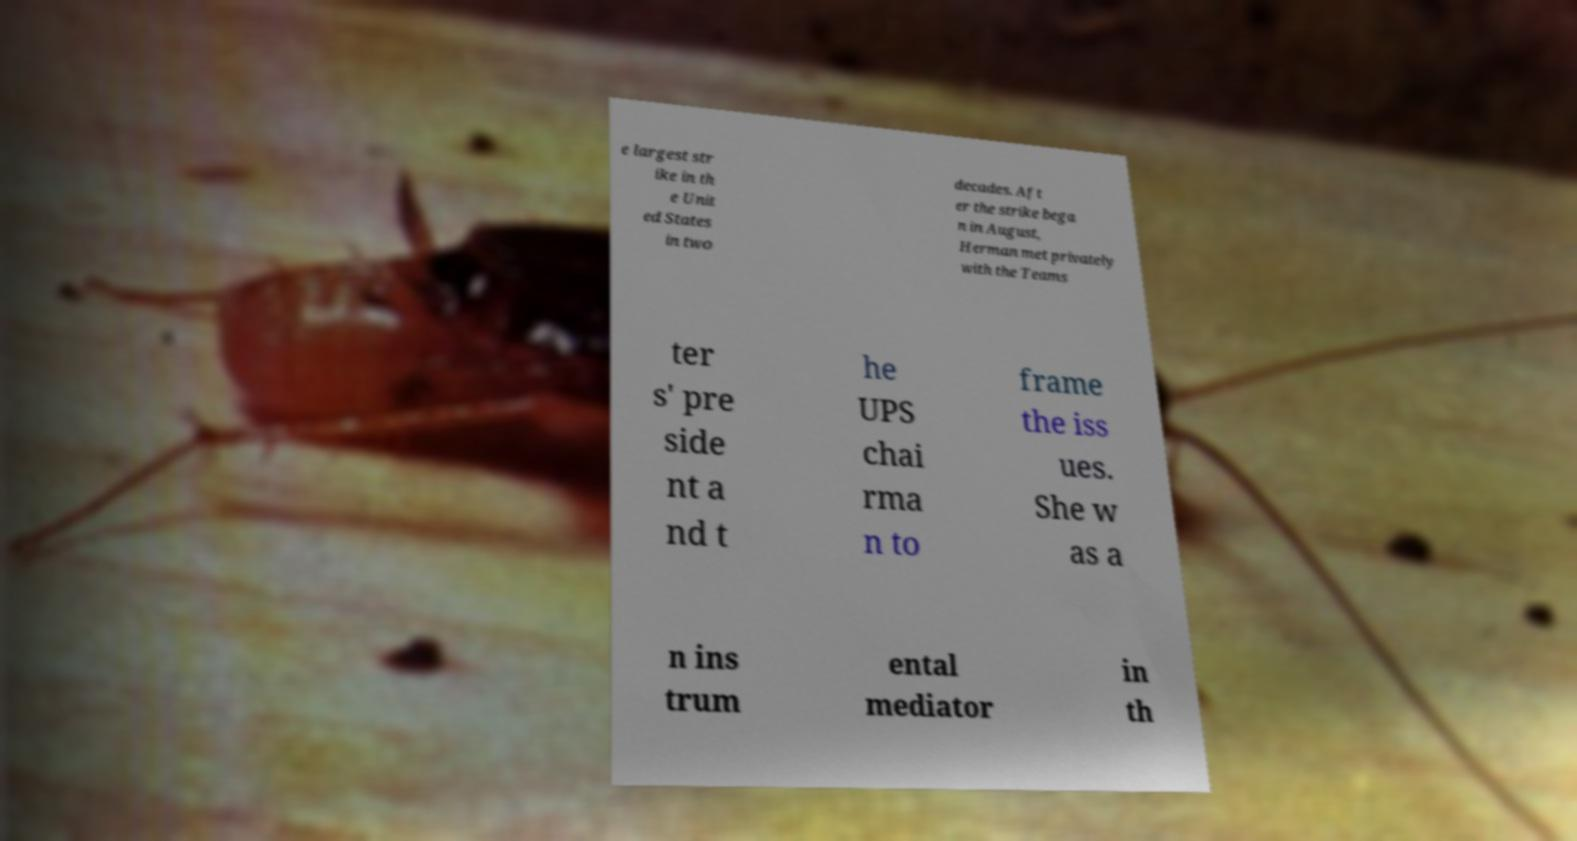For documentation purposes, I need the text within this image transcribed. Could you provide that? e largest str ike in th e Unit ed States in two decades. Aft er the strike bega n in August, Herman met privately with the Teams ter s' pre side nt a nd t he UPS chai rma n to frame the iss ues. She w as a n ins trum ental mediator in th 